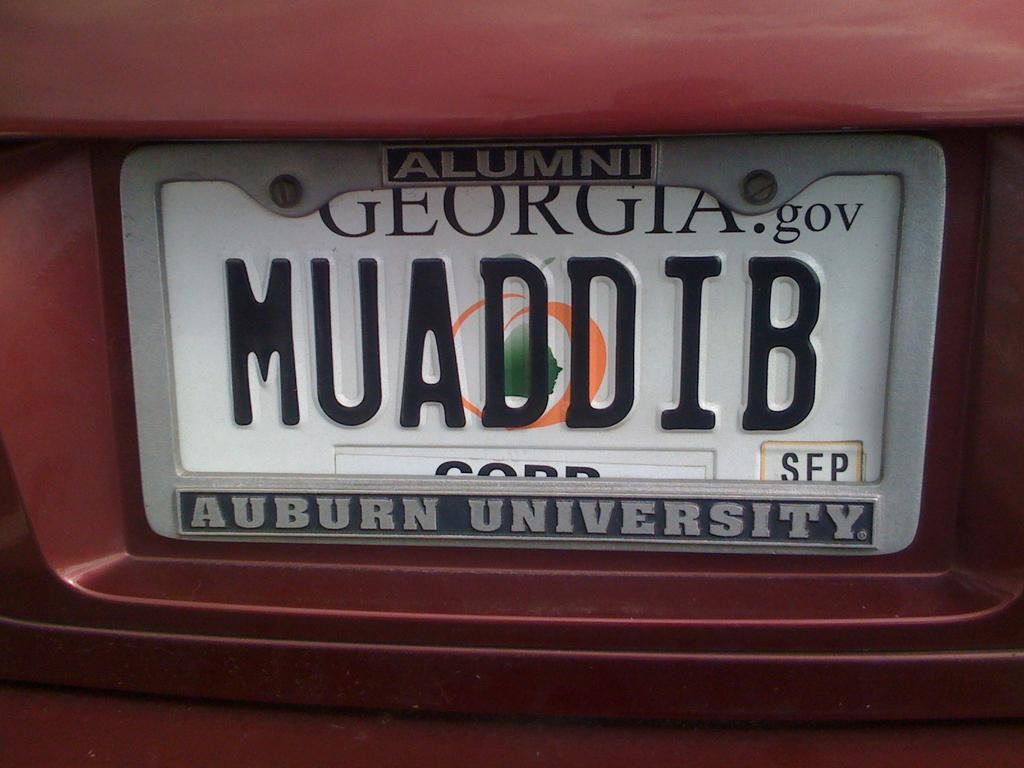What university is on the plate cover?
Your answer should be very brief. Auburn. 